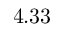Convert formula to latex. <formula><loc_0><loc_0><loc_500><loc_500>4 . 3 3</formula> 